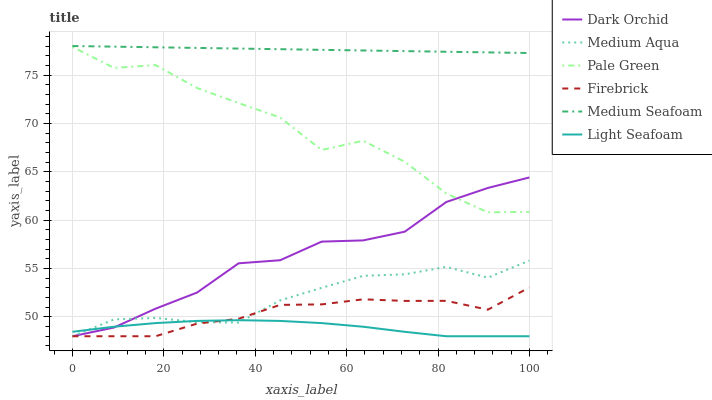Does Light Seafoam have the minimum area under the curve?
Answer yes or no. Yes. Does Medium Seafoam have the maximum area under the curve?
Answer yes or no. Yes. Does Dark Orchid have the minimum area under the curve?
Answer yes or no. No. Does Dark Orchid have the maximum area under the curve?
Answer yes or no. No. Is Medium Seafoam the smoothest?
Answer yes or no. Yes. Is Pale Green the roughest?
Answer yes or no. Yes. Is Dark Orchid the smoothest?
Answer yes or no. No. Is Dark Orchid the roughest?
Answer yes or no. No. Does Firebrick have the lowest value?
Answer yes or no. Yes. Does Pale Green have the lowest value?
Answer yes or no. No. Does Medium Seafoam have the highest value?
Answer yes or no. Yes. Does Dark Orchid have the highest value?
Answer yes or no. No. Is Medium Aqua less than Medium Seafoam?
Answer yes or no. Yes. Is Pale Green greater than Medium Aqua?
Answer yes or no. Yes. Does Medium Aqua intersect Light Seafoam?
Answer yes or no. Yes. Is Medium Aqua less than Light Seafoam?
Answer yes or no. No. Is Medium Aqua greater than Light Seafoam?
Answer yes or no. No. Does Medium Aqua intersect Medium Seafoam?
Answer yes or no. No. 